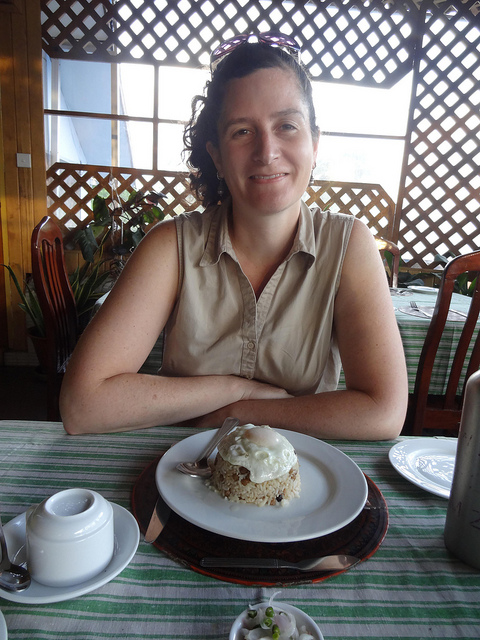<image>What kind of plant is in the background? It's unclear what kind of plant is in the background. It could be a houseplant, a fern, or a vine. What kind of plant is in the background? It is ambiguous what kind of plant is in the background. It can be seen as a houseplant, fern, potted plant, vine, or green plant. 